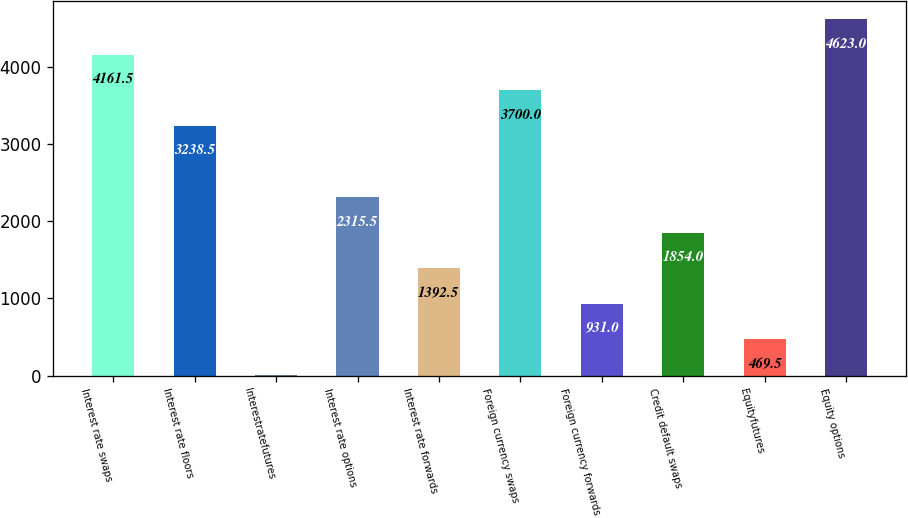<chart> <loc_0><loc_0><loc_500><loc_500><bar_chart><fcel>Interest rate swaps<fcel>Interest rate floors<fcel>Interestratefutures<fcel>Interest rate options<fcel>Interest rate forwards<fcel>Foreign currency swaps<fcel>Foreign currency forwards<fcel>Credit default swaps<fcel>Equityfutures<fcel>Equity options<nl><fcel>4161.5<fcel>3238.5<fcel>8<fcel>2315.5<fcel>1392.5<fcel>3700<fcel>931<fcel>1854<fcel>469.5<fcel>4623<nl></chart> 